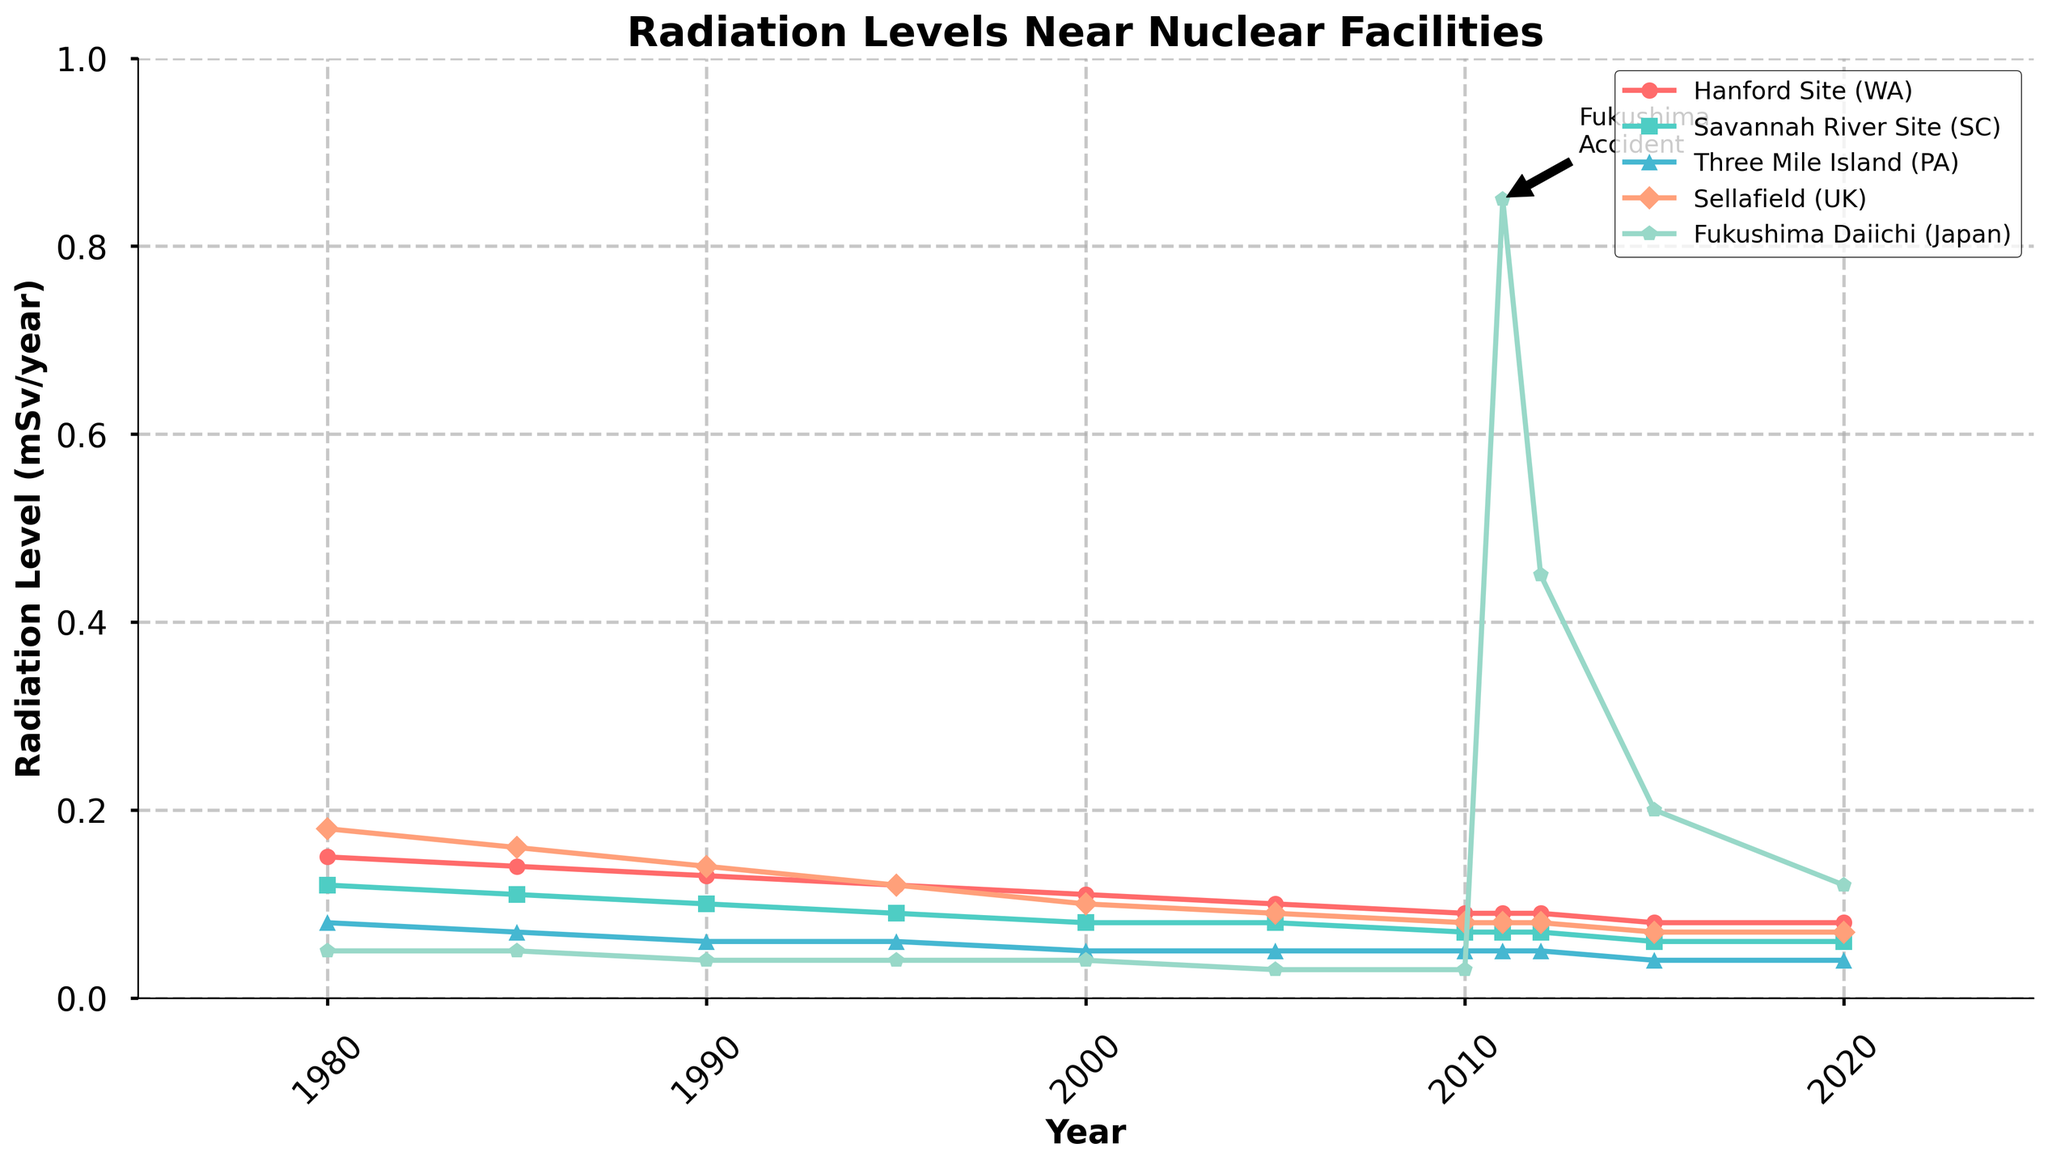When did the radiation level at Fukushima Daiichi peak? The highest point on the Fukushima Daiichi line is in the year 2011 with a radiation level significantly higher than other years.
Answer: 2011 Which site had the highest radiation level in 1980? Looking at the vertical positions of the lines in 1980, the Sellafield (UK) line is the highest, indicating the highest radiation level.
Answer: Sellafield (UK) Between 1980 and 2020, which site experienced the most significant drop in radiation levels? Calculating the difference from 1980 to 2020 for each site, the Hanford Site (WA) dropped from 0.15 to 0.08 (0.07), Savannah River Site (SC) from 0.12 to 0.06 (0.06), Three Mile Island (PA) from 0.08 to 0.04 (0.04), Sellafield (UK) from 0.18 to 0.07 (0.11), Fukushima Daiichi from 0.05 to 0.12 (-0.07). Sellafield (UK) shows the most significant decline (0.11).
Answer: Sellafield (UK) What was the average radiation level across all sites in 2000? Summing up the radiation levels in 2000: 0.11 (Hanford Site) + 0.08 (Savannah River Site) + 0.05 (Three Mile Island) + 0.10 (Sellafield) + 0.04 (Fukushima). The total is 0.38. Dividing by the number of sites (5) gives an average of 0.076.
Answer: 0.076 How did the radiation levels of Fukushima Daiichi change from 2011 to 2012? The Fukushima Daiichi line shows a dramatic drop from 0.85 in 2011 to 0.45 in 2012.
Answer: Decreased significantly Which nuclear facility had the most consistent decrease in radiation levels between 1980 and 2005? Considering the slope of each line from 1980 to 2005, the Hanford Site (WA) shows a steady and consistent decrease without any abrupt changes.
Answer: Hanford Site (WA) In 1990, were the radiation levels at Three Mile Island higher or lower than those at the Savannah River Site? Comparing the vertical positions of Three Mile Island (0.06) and Savannah River Site (0.10) in 1990, Three Mile Island is lower.
Answer: Lower What was the difference in radiation levels between the Hanford Site and the Savannah River Site in 1980? Subtracting the radiation level of the Savannah River Site (0.12) from the Hanford Site (0.15) in 1980 gives a difference of 0.03.
Answer: 0.03 How do the 2020 radiation levels at Sellafield compare to those at Fukushima Daiichi? Looking at the endpoints of the lines in 2020, Sellafield has a radiation level of 0.07, while Fukushima Daiichi has 0.12. Sellafield's radiation level is lower.
Answer: Sellafield is lower What significant event is annotated in the chart, and what year does it correspond to? The annotation "Fukushima Accident" points to the year 2011 with an arrow and text.
Answer: Fukushima Accident, 2011 